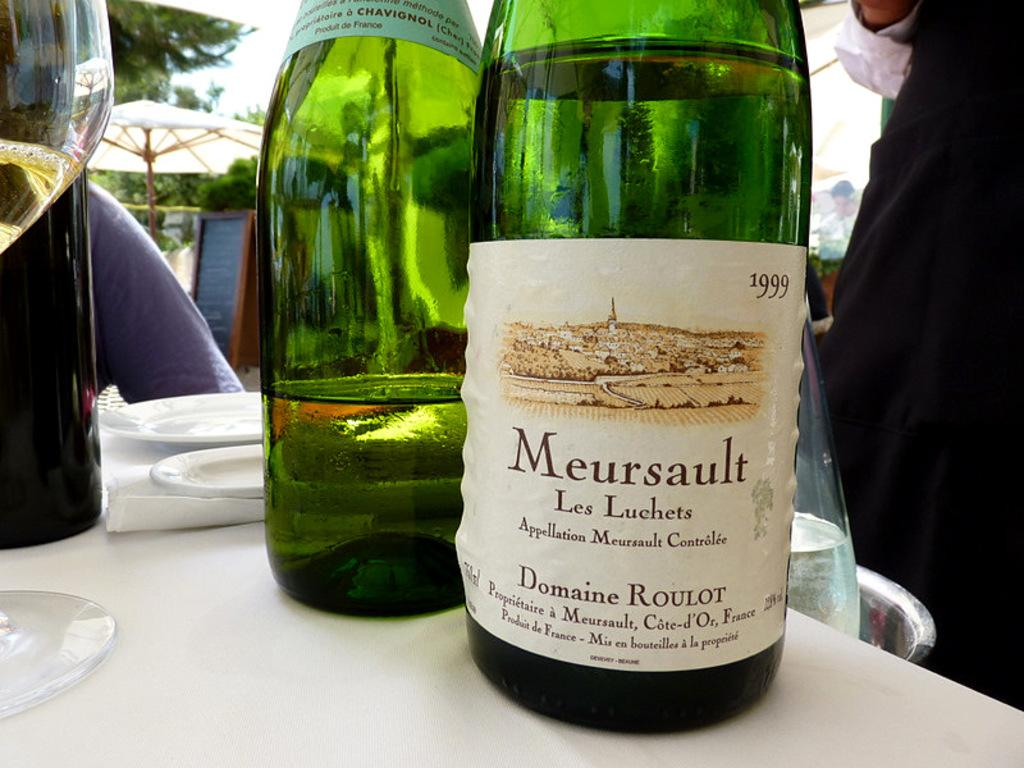<image>
Provide a brief description of the given image. A green bottled of Meursault bottled in 1999 is sitting on a white table cloth. 